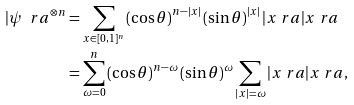Convert formula to latex. <formula><loc_0><loc_0><loc_500><loc_500>| \psi \ r a ^ { \otimes n } & = \sum _ { x \in [ 0 , 1 ] ^ { n } } \left ( \cos { \theta } \right ) ^ { n - | x | } \left ( \sin { \theta } \right ) ^ { | x | } | x \ r a | x \ r a \\ & = \sum _ { \omega = 0 } ^ { n } \left ( \cos { \theta } \right ) ^ { n - \omega } \left ( \sin { \theta } \right ) ^ { \omega } \sum _ { | x | = \omega } | x \ r a | x \ r a ,</formula> 